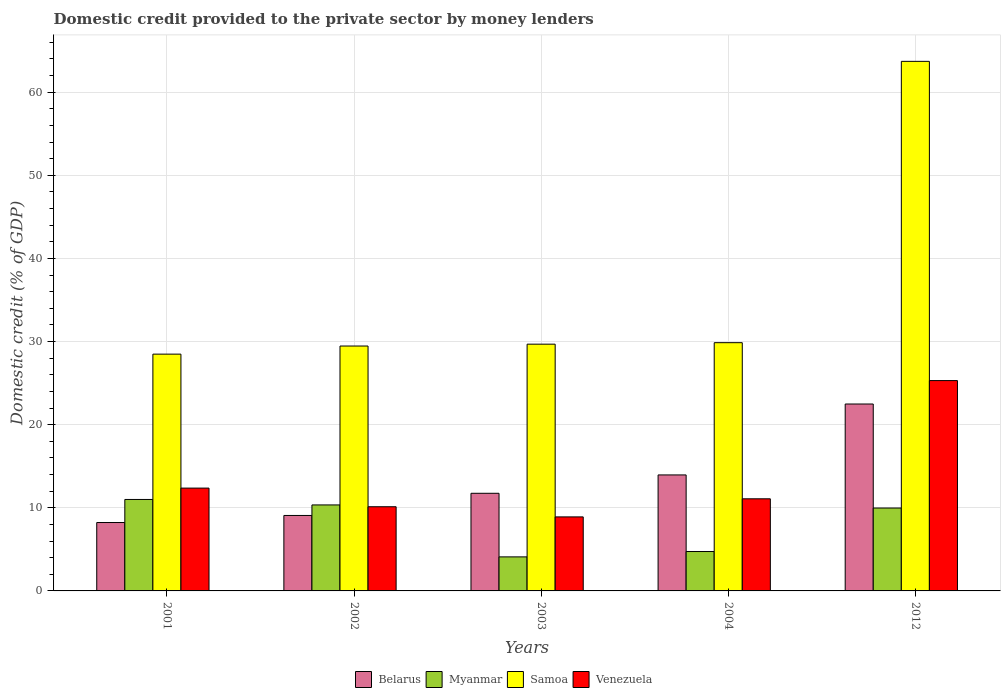How many groups of bars are there?
Your answer should be compact. 5. Are the number of bars per tick equal to the number of legend labels?
Offer a terse response. Yes. Are the number of bars on each tick of the X-axis equal?
Your answer should be very brief. Yes. How many bars are there on the 5th tick from the left?
Ensure brevity in your answer.  4. How many bars are there on the 5th tick from the right?
Offer a very short reply. 4. In how many cases, is the number of bars for a given year not equal to the number of legend labels?
Make the answer very short. 0. What is the domestic credit provided to the private sector by money lenders in Myanmar in 2001?
Give a very brief answer. 11. Across all years, what is the maximum domestic credit provided to the private sector by money lenders in Venezuela?
Offer a very short reply. 25.3. Across all years, what is the minimum domestic credit provided to the private sector by money lenders in Myanmar?
Your answer should be very brief. 4.1. In which year was the domestic credit provided to the private sector by money lenders in Myanmar minimum?
Your answer should be very brief. 2003. What is the total domestic credit provided to the private sector by money lenders in Myanmar in the graph?
Provide a succinct answer. 40.16. What is the difference between the domestic credit provided to the private sector by money lenders in Venezuela in 2001 and that in 2002?
Provide a short and direct response. 2.24. What is the difference between the domestic credit provided to the private sector by money lenders in Myanmar in 2012 and the domestic credit provided to the private sector by money lenders in Samoa in 2002?
Your answer should be very brief. -19.49. What is the average domestic credit provided to the private sector by money lenders in Myanmar per year?
Your answer should be very brief. 8.03. In the year 2004, what is the difference between the domestic credit provided to the private sector by money lenders in Myanmar and domestic credit provided to the private sector by money lenders in Belarus?
Provide a succinct answer. -9.21. What is the ratio of the domestic credit provided to the private sector by money lenders in Samoa in 2002 to that in 2012?
Your response must be concise. 0.46. Is the difference between the domestic credit provided to the private sector by money lenders in Myanmar in 2002 and 2004 greater than the difference between the domestic credit provided to the private sector by money lenders in Belarus in 2002 and 2004?
Make the answer very short. Yes. What is the difference between the highest and the second highest domestic credit provided to the private sector by money lenders in Myanmar?
Provide a short and direct response. 0.66. What is the difference between the highest and the lowest domestic credit provided to the private sector by money lenders in Samoa?
Give a very brief answer. 35.22. In how many years, is the domestic credit provided to the private sector by money lenders in Venezuela greater than the average domestic credit provided to the private sector by money lenders in Venezuela taken over all years?
Ensure brevity in your answer.  1. Is it the case that in every year, the sum of the domestic credit provided to the private sector by money lenders in Belarus and domestic credit provided to the private sector by money lenders in Venezuela is greater than the sum of domestic credit provided to the private sector by money lenders in Samoa and domestic credit provided to the private sector by money lenders in Myanmar?
Keep it short and to the point. No. What does the 1st bar from the left in 2004 represents?
Provide a short and direct response. Belarus. What does the 2nd bar from the right in 2004 represents?
Your answer should be compact. Samoa. How many bars are there?
Give a very brief answer. 20. Are all the bars in the graph horizontal?
Make the answer very short. No. How many years are there in the graph?
Your answer should be very brief. 5. What is the difference between two consecutive major ticks on the Y-axis?
Offer a terse response. 10. Are the values on the major ticks of Y-axis written in scientific E-notation?
Offer a terse response. No. Does the graph contain any zero values?
Offer a terse response. No. Where does the legend appear in the graph?
Your answer should be very brief. Bottom center. How many legend labels are there?
Keep it short and to the point. 4. How are the legend labels stacked?
Offer a terse response. Horizontal. What is the title of the graph?
Provide a short and direct response. Domestic credit provided to the private sector by money lenders. Does "Somalia" appear as one of the legend labels in the graph?
Offer a terse response. No. What is the label or title of the X-axis?
Offer a very short reply. Years. What is the label or title of the Y-axis?
Provide a succinct answer. Domestic credit (% of GDP). What is the Domestic credit (% of GDP) in Belarus in 2001?
Offer a very short reply. 8.23. What is the Domestic credit (% of GDP) of Myanmar in 2001?
Your answer should be compact. 11. What is the Domestic credit (% of GDP) of Samoa in 2001?
Make the answer very short. 28.49. What is the Domestic credit (% of GDP) of Venezuela in 2001?
Provide a succinct answer. 12.37. What is the Domestic credit (% of GDP) of Belarus in 2002?
Your answer should be very brief. 9.08. What is the Domestic credit (% of GDP) in Myanmar in 2002?
Keep it short and to the point. 10.34. What is the Domestic credit (% of GDP) in Samoa in 2002?
Give a very brief answer. 29.46. What is the Domestic credit (% of GDP) of Venezuela in 2002?
Provide a short and direct response. 10.13. What is the Domestic credit (% of GDP) of Belarus in 2003?
Your answer should be very brief. 11.75. What is the Domestic credit (% of GDP) in Myanmar in 2003?
Provide a succinct answer. 4.1. What is the Domestic credit (% of GDP) in Samoa in 2003?
Keep it short and to the point. 29.69. What is the Domestic credit (% of GDP) in Venezuela in 2003?
Ensure brevity in your answer.  8.91. What is the Domestic credit (% of GDP) in Belarus in 2004?
Make the answer very short. 13.95. What is the Domestic credit (% of GDP) of Myanmar in 2004?
Keep it short and to the point. 4.74. What is the Domestic credit (% of GDP) in Samoa in 2004?
Your response must be concise. 29.87. What is the Domestic credit (% of GDP) in Venezuela in 2004?
Keep it short and to the point. 11.08. What is the Domestic credit (% of GDP) of Belarus in 2012?
Offer a very short reply. 22.49. What is the Domestic credit (% of GDP) of Myanmar in 2012?
Offer a terse response. 9.97. What is the Domestic credit (% of GDP) in Samoa in 2012?
Offer a terse response. 63.71. What is the Domestic credit (% of GDP) in Venezuela in 2012?
Offer a very short reply. 25.3. Across all years, what is the maximum Domestic credit (% of GDP) in Belarus?
Keep it short and to the point. 22.49. Across all years, what is the maximum Domestic credit (% of GDP) of Myanmar?
Offer a terse response. 11. Across all years, what is the maximum Domestic credit (% of GDP) in Samoa?
Your response must be concise. 63.71. Across all years, what is the maximum Domestic credit (% of GDP) in Venezuela?
Your answer should be compact. 25.3. Across all years, what is the minimum Domestic credit (% of GDP) in Belarus?
Offer a terse response. 8.23. Across all years, what is the minimum Domestic credit (% of GDP) of Myanmar?
Make the answer very short. 4.1. Across all years, what is the minimum Domestic credit (% of GDP) of Samoa?
Your answer should be compact. 28.49. Across all years, what is the minimum Domestic credit (% of GDP) of Venezuela?
Ensure brevity in your answer.  8.91. What is the total Domestic credit (% of GDP) in Belarus in the graph?
Provide a short and direct response. 65.49. What is the total Domestic credit (% of GDP) in Myanmar in the graph?
Your response must be concise. 40.16. What is the total Domestic credit (% of GDP) in Samoa in the graph?
Offer a very short reply. 181.21. What is the total Domestic credit (% of GDP) in Venezuela in the graph?
Your response must be concise. 67.79. What is the difference between the Domestic credit (% of GDP) of Belarus in 2001 and that in 2002?
Provide a short and direct response. -0.85. What is the difference between the Domestic credit (% of GDP) of Myanmar in 2001 and that in 2002?
Your answer should be very brief. 0.66. What is the difference between the Domestic credit (% of GDP) of Samoa in 2001 and that in 2002?
Offer a terse response. -0.98. What is the difference between the Domestic credit (% of GDP) of Venezuela in 2001 and that in 2002?
Ensure brevity in your answer.  2.24. What is the difference between the Domestic credit (% of GDP) in Belarus in 2001 and that in 2003?
Offer a very short reply. -3.52. What is the difference between the Domestic credit (% of GDP) of Myanmar in 2001 and that in 2003?
Your answer should be very brief. 6.91. What is the difference between the Domestic credit (% of GDP) of Samoa in 2001 and that in 2003?
Your answer should be compact. -1.2. What is the difference between the Domestic credit (% of GDP) in Venezuela in 2001 and that in 2003?
Ensure brevity in your answer.  3.46. What is the difference between the Domestic credit (% of GDP) in Belarus in 2001 and that in 2004?
Keep it short and to the point. -5.72. What is the difference between the Domestic credit (% of GDP) of Myanmar in 2001 and that in 2004?
Make the answer very short. 6.26. What is the difference between the Domestic credit (% of GDP) of Samoa in 2001 and that in 2004?
Make the answer very short. -1.38. What is the difference between the Domestic credit (% of GDP) of Venezuela in 2001 and that in 2004?
Offer a very short reply. 1.29. What is the difference between the Domestic credit (% of GDP) in Belarus in 2001 and that in 2012?
Keep it short and to the point. -14.26. What is the difference between the Domestic credit (% of GDP) of Myanmar in 2001 and that in 2012?
Offer a terse response. 1.03. What is the difference between the Domestic credit (% of GDP) of Samoa in 2001 and that in 2012?
Make the answer very short. -35.22. What is the difference between the Domestic credit (% of GDP) of Venezuela in 2001 and that in 2012?
Give a very brief answer. -12.93. What is the difference between the Domestic credit (% of GDP) in Belarus in 2002 and that in 2003?
Make the answer very short. -2.67. What is the difference between the Domestic credit (% of GDP) in Myanmar in 2002 and that in 2003?
Offer a very short reply. 6.25. What is the difference between the Domestic credit (% of GDP) of Samoa in 2002 and that in 2003?
Ensure brevity in your answer.  -0.22. What is the difference between the Domestic credit (% of GDP) in Venezuela in 2002 and that in 2003?
Give a very brief answer. 1.22. What is the difference between the Domestic credit (% of GDP) of Belarus in 2002 and that in 2004?
Your answer should be very brief. -4.88. What is the difference between the Domestic credit (% of GDP) of Myanmar in 2002 and that in 2004?
Your answer should be very brief. 5.6. What is the difference between the Domestic credit (% of GDP) in Samoa in 2002 and that in 2004?
Provide a short and direct response. -0.4. What is the difference between the Domestic credit (% of GDP) in Venezuela in 2002 and that in 2004?
Offer a very short reply. -0.95. What is the difference between the Domestic credit (% of GDP) of Belarus in 2002 and that in 2012?
Make the answer very short. -13.41. What is the difference between the Domestic credit (% of GDP) of Myanmar in 2002 and that in 2012?
Your response must be concise. 0.37. What is the difference between the Domestic credit (% of GDP) of Samoa in 2002 and that in 2012?
Your response must be concise. -34.25. What is the difference between the Domestic credit (% of GDP) of Venezuela in 2002 and that in 2012?
Provide a short and direct response. -15.18. What is the difference between the Domestic credit (% of GDP) of Belarus in 2003 and that in 2004?
Offer a terse response. -2.21. What is the difference between the Domestic credit (% of GDP) in Myanmar in 2003 and that in 2004?
Keep it short and to the point. -0.64. What is the difference between the Domestic credit (% of GDP) of Samoa in 2003 and that in 2004?
Your answer should be compact. -0.18. What is the difference between the Domestic credit (% of GDP) of Venezuela in 2003 and that in 2004?
Offer a very short reply. -2.18. What is the difference between the Domestic credit (% of GDP) of Belarus in 2003 and that in 2012?
Keep it short and to the point. -10.74. What is the difference between the Domestic credit (% of GDP) of Myanmar in 2003 and that in 2012?
Your response must be concise. -5.88. What is the difference between the Domestic credit (% of GDP) of Samoa in 2003 and that in 2012?
Offer a terse response. -34.02. What is the difference between the Domestic credit (% of GDP) in Venezuela in 2003 and that in 2012?
Offer a terse response. -16.4. What is the difference between the Domestic credit (% of GDP) in Belarus in 2004 and that in 2012?
Offer a terse response. -8.53. What is the difference between the Domestic credit (% of GDP) in Myanmar in 2004 and that in 2012?
Offer a terse response. -5.23. What is the difference between the Domestic credit (% of GDP) of Samoa in 2004 and that in 2012?
Offer a terse response. -33.84. What is the difference between the Domestic credit (% of GDP) in Venezuela in 2004 and that in 2012?
Ensure brevity in your answer.  -14.22. What is the difference between the Domestic credit (% of GDP) in Belarus in 2001 and the Domestic credit (% of GDP) in Myanmar in 2002?
Your answer should be compact. -2.12. What is the difference between the Domestic credit (% of GDP) of Belarus in 2001 and the Domestic credit (% of GDP) of Samoa in 2002?
Ensure brevity in your answer.  -21.23. What is the difference between the Domestic credit (% of GDP) of Belarus in 2001 and the Domestic credit (% of GDP) of Venezuela in 2002?
Make the answer very short. -1.9. What is the difference between the Domestic credit (% of GDP) in Myanmar in 2001 and the Domestic credit (% of GDP) in Samoa in 2002?
Make the answer very short. -18.46. What is the difference between the Domestic credit (% of GDP) in Myanmar in 2001 and the Domestic credit (% of GDP) in Venezuela in 2002?
Your answer should be compact. 0.88. What is the difference between the Domestic credit (% of GDP) in Samoa in 2001 and the Domestic credit (% of GDP) in Venezuela in 2002?
Provide a short and direct response. 18.36. What is the difference between the Domestic credit (% of GDP) of Belarus in 2001 and the Domestic credit (% of GDP) of Myanmar in 2003?
Ensure brevity in your answer.  4.13. What is the difference between the Domestic credit (% of GDP) in Belarus in 2001 and the Domestic credit (% of GDP) in Samoa in 2003?
Provide a short and direct response. -21.46. What is the difference between the Domestic credit (% of GDP) of Belarus in 2001 and the Domestic credit (% of GDP) of Venezuela in 2003?
Make the answer very short. -0.68. What is the difference between the Domestic credit (% of GDP) of Myanmar in 2001 and the Domestic credit (% of GDP) of Samoa in 2003?
Provide a succinct answer. -18.68. What is the difference between the Domestic credit (% of GDP) in Myanmar in 2001 and the Domestic credit (% of GDP) in Venezuela in 2003?
Provide a short and direct response. 2.1. What is the difference between the Domestic credit (% of GDP) of Samoa in 2001 and the Domestic credit (% of GDP) of Venezuela in 2003?
Offer a terse response. 19.58. What is the difference between the Domestic credit (% of GDP) of Belarus in 2001 and the Domestic credit (% of GDP) of Myanmar in 2004?
Offer a very short reply. 3.49. What is the difference between the Domestic credit (% of GDP) of Belarus in 2001 and the Domestic credit (% of GDP) of Samoa in 2004?
Offer a very short reply. -21.64. What is the difference between the Domestic credit (% of GDP) in Belarus in 2001 and the Domestic credit (% of GDP) in Venezuela in 2004?
Provide a succinct answer. -2.85. What is the difference between the Domestic credit (% of GDP) in Myanmar in 2001 and the Domestic credit (% of GDP) in Samoa in 2004?
Your response must be concise. -18.86. What is the difference between the Domestic credit (% of GDP) of Myanmar in 2001 and the Domestic credit (% of GDP) of Venezuela in 2004?
Offer a very short reply. -0.08. What is the difference between the Domestic credit (% of GDP) of Samoa in 2001 and the Domestic credit (% of GDP) of Venezuela in 2004?
Offer a very short reply. 17.4. What is the difference between the Domestic credit (% of GDP) in Belarus in 2001 and the Domestic credit (% of GDP) in Myanmar in 2012?
Offer a very short reply. -1.74. What is the difference between the Domestic credit (% of GDP) of Belarus in 2001 and the Domestic credit (% of GDP) of Samoa in 2012?
Provide a short and direct response. -55.48. What is the difference between the Domestic credit (% of GDP) in Belarus in 2001 and the Domestic credit (% of GDP) in Venezuela in 2012?
Your response must be concise. -17.07. What is the difference between the Domestic credit (% of GDP) in Myanmar in 2001 and the Domestic credit (% of GDP) in Samoa in 2012?
Give a very brief answer. -52.71. What is the difference between the Domestic credit (% of GDP) in Myanmar in 2001 and the Domestic credit (% of GDP) in Venezuela in 2012?
Keep it short and to the point. -14.3. What is the difference between the Domestic credit (% of GDP) in Samoa in 2001 and the Domestic credit (% of GDP) in Venezuela in 2012?
Offer a very short reply. 3.18. What is the difference between the Domestic credit (% of GDP) of Belarus in 2002 and the Domestic credit (% of GDP) of Myanmar in 2003?
Offer a terse response. 4.98. What is the difference between the Domestic credit (% of GDP) of Belarus in 2002 and the Domestic credit (% of GDP) of Samoa in 2003?
Provide a succinct answer. -20.61. What is the difference between the Domestic credit (% of GDP) of Belarus in 2002 and the Domestic credit (% of GDP) of Venezuela in 2003?
Ensure brevity in your answer.  0.17. What is the difference between the Domestic credit (% of GDP) of Myanmar in 2002 and the Domestic credit (% of GDP) of Samoa in 2003?
Offer a very short reply. -19.34. What is the difference between the Domestic credit (% of GDP) of Myanmar in 2002 and the Domestic credit (% of GDP) of Venezuela in 2003?
Ensure brevity in your answer.  1.44. What is the difference between the Domestic credit (% of GDP) in Samoa in 2002 and the Domestic credit (% of GDP) in Venezuela in 2003?
Offer a very short reply. 20.56. What is the difference between the Domestic credit (% of GDP) in Belarus in 2002 and the Domestic credit (% of GDP) in Myanmar in 2004?
Provide a succinct answer. 4.34. What is the difference between the Domestic credit (% of GDP) of Belarus in 2002 and the Domestic credit (% of GDP) of Samoa in 2004?
Offer a terse response. -20.79. What is the difference between the Domestic credit (% of GDP) in Belarus in 2002 and the Domestic credit (% of GDP) in Venezuela in 2004?
Offer a very short reply. -2. What is the difference between the Domestic credit (% of GDP) of Myanmar in 2002 and the Domestic credit (% of GDP) of Samoa in 2004?
Give a very brief answer. -19.52. What is the difference between the Domestic credit (% of GDP) of Myanmar in 2002 and the Domestic credit (% of GDP) of Venezuela in 2004?
Offer a terse response. -0.74. What is the difference between the Domestic credit (% of GDP) in Samoa in 2002 and the Domestic credit (% of GDP) in Venezuela in 2004?
Your answer should be very brief. 18.38. What is the difference between the Domestic credit (% of GDP) in Belarus in 2002 and the Domestic credit (% of GDP) in Myanmar in 2012?
Make the answer very short. -0.9. What is the difference between the Domestic credit (% of GDP) in Belarus in 2002 and the Domestic credit (% of GDP) in Samoa in 2012?
Give a very brief answer. -54.63. What is the difference between the Domestic credit (% of GDP) in Belarus in 2002 and the Domestic credit (% of GDP) in Venezuela in 2012?
Your response must be concise. -16.23. What is the difference between the Domestic credit (% of GDP) in Myanmar in 2002 and the Domestic credit (% of GDP) in Samoa in 2012?
Provide a short and direct response. -53.36. What is the difference between the Domestic credit (% of GDP) of Myanmar in 2002 and the Domestic credit (% of GDP) of Venezuela in 2012?
Make the answer very short. -14.96. What is the difference between the Domestic credit (% of GDP) of Samoa in 2002 and the Domestic credit (% of GDP) of Venezuela in 2012?
Offer a terse response. 4.16. What is the difference between the Domestic credit (% of GDP) of Belarus in 2003 and the Domestic credit (% of GDP) of Myanmar in 2004?
Offer a very short reply. 7.01. What is the difference between the Domestic credit (% of GDP) of Belarus in 2003 and the Domestic credit (% of GDP) of Samoa in 2004?
Offer a very short reply. -18.12. What is the difference between the Domestic credit (% of GDP) in Belarus in 2003 and the Domestic credit (% of GDP) in Venezuela in 2004?
Your answer should be compact. 0.66. What is the difference between the Domestic credit (% of GDP) of Myanmar in 2003 and the Domestic credit (% of GDP) of Samoa in 2004?
Provide a succinct answer. -25.77. What is the difference between the Domestic credit (% of GDP) in Myanmar in 2003 and the Domestic credit (% of GDP) in Venezuela in 2004?
Your answer should be compact. -6.99. What is the difference between the Domestic credit (% of GDP) in Samoa in 2003 and the Domestic credit (% of GDP) in Venezuela in 2004?
Provide a short and direct response. 18.6. What is the difference between the Domestic credit (% of GDP) of Belarus in 2003 and the Domestic credit (% of GDP) of Myanmar in 2012?
Offer a very short reply. 1.77. What is the difference between the Domestic credit (% of GDP) in Belarus in 2003 and the Domestic credit (% of GDP) in Samoa in 2012?
Give a very brief answer. -51.96. What is the difference between the Domestic credit (% of GDP) of Belarus in 2003 and the Domestic credit (% of GDP) of Venezuela in 2012?
Provide a short and direct response. -13.56. What is the difference between the Domestic credit (% of GDP) in Myanmar in 2003 and the Domestic credit (% of GDP) in Samoa in 2012?
Offer a very short reply. -59.61. What is the difference between the Domestic credit (% of GDP) in Myanmar in 2003 and the Domestic credit (% of GDP) in Venezuela in 2012?
Give a very brief answer. -21.21. What is the difference between the Domestic credit (% of GDP) of Samoa in 2003 and the Domestic credit (% of GDP) of Venezuela in 2012?
Your answer should be compact. 4.38. What is the difference between the Domestic credit (% of GDP) in Belarus in 2004 and the Domestic credit (% of GDP) in Myanmar in 2012?
Provide a succinct answer. 3.98. What is the difference between the Domestic credit (% of GDP) of Belarus in 2004 and the Domestic credit (% of GDP) of Samoa in 2012?
Offer a very short reply. -49.76. What is the difference between the Domestic credit (% of GDP) of Belarus in 2004 and the Domestic credit (% of GDP) of Venezuela in 2012?
Your response must be concise. -11.35. What is the difference between the Domestic credit (% of GDP) in Myanmar in 2004 and the Domestic credit (% of GDP) in Samoa in 2012?
Your response must be concise. -58.97. What is the difference between the Domestic credit (% of GDP) of Myanmar in 2004 and the Domestic credit (% of GDP) of Venezuela in 2012?
Provide a succinct answer. -20.56. What is the difference between the Domestic credit (% of GDP) of Samoa in 2004 and the Domestic credit (% of GDP) of Venezuela in 2012?
Provide a succinct answer. 4.56. What is the average Domestic credit (% of GDP) in Belarus per year?
Provide a succinct answer. 13.1. What is the average Domestic credit (% of GDP) in Myanmar per year?
Offer a very short reply. 8.03. What is the average Domestic credit (% of GDP) of Samoa per year?
Offer a terse response. 36.24. What is the average Domestic credit (% of GDP) of Venezuela per year?
Your answer should be compact. 13.56. In the year 2001, what is the difference between the Domestic credit (% of GDP) in Belarus and Domestic credit (% of GDP) in Myanmar?
Your answer should be very brief. -2.77. In the year 2001, what is the difference between the Domestic credit (% of GDP) in Belarus and Domestic credit (% of GDP) in Samoa?
Give a very brief answer. -20.26. In the year 2001, what is the difference between the Domestic credit (% of GDP) in Belarus and Domestic credit (% of GDP) in Venezuela?
Offer a terse response. -4.14. In the year 2001, what is the difference between the Domestic credit (% of GDP) in Myanmar and Domestic credit (% of GDP) in Samoa?
Give a very brief answer. -17.48. In the year 2001, what is the difference between the Domestic credit (% of GDP) of Myanmar and Domestic credit (% of GDP) of Venezuela?
Give a very brief answer. -1.37. In the year 2001, what is the difference between the Domestic credit (% of GDP) of Samoa and Domestic credit (% of GDP) of Venezuela?
Keep it short and to the point. 16.12. In the year 2002, what is the difference between the Domestic credit (% of GDP) in Belarus and Domestic credit (% of GDP) in Myanmar?
Offer a terse response. -1.27. In the year 2002, what is the difference between the Domestic credit (% of GDP) in Belarus and Domestic credit (% of GDP) in Samoa?
Your answer should be compact. -20.38. In the year 2002, what is the difference between the Domestic credit (% of GDP) in Belarus and Domestic credit (% of GDP) in Venezuela?
Offer a terse response. -1.05. In the year 2002, what is the difference between the Domestic credit (% of GDP) of Myanmar and Domestic credit (% of GDP) of Samoa?
Provide a short and direct response. -19.12. In the year 2002, what is the difference between the Domestic credit (% of GDP) in Myanmar and Domestic credit (% of GDP) in Venezuela?
Offer a terse response. 0.22. In the year 2002, what is the difference between the Domestic credit (% of GDP) in Samoa and Domestic credit (% of GDP) in Venezuela?
Your response must be concise. 19.33. In the year 2003, what is the difference between the Domestic credit (% of GDP) in Belarus and Domestic credit (% of GDP) in Myanmar?
Offer a terse response. 7.65. In the year 2003, what is the difference between the Domestic credit (% of GDP) of Belarus and Domestic credit (% of GDP) of Samoa?
Your answer should be very brief. -17.94. In the year 2003, what is the difference between the Domestic credit (% of GDP) in Belarus and Domestic credit (% of GDP) in Venezuela?
Your answer should be very brief. 2.84. In the year 2003, what is the difference between the Domestic credit (% of GDP) of Myanmar and Domestic credit (% of GDP) of Samoa?
Offer a terse response. -25.59. In the year 2003, what is the difference between the Domestic credit (% of GDP) in Myanmar and Domestic credit (% of GDP) in Venezuela?
Keep it short and to the point. -4.81. In the year 2003, what is the difference between the Domestic credit (% of GDP) of Samoa and Domestic credit (% of GDP) of Venezuela?
Make the answer very short. 20.78. In the year 2004, what is the difference between the Domestic credit (% of GDP) of Belarus and Domestic credit (% of GDP) of Myanmar?
Offer a terse response. 9.21. In the year 2004, what is the difference between the Domestic credit (% of GDP) in Belarus and Domestic credit (% of GDP) in Samoa?
Give a very brief answer. -15.91. In the year 2004, what is the difference between the Domestic credit (% of GDP) of Belarus and Domestic credit (% of GDP) of Venezuela?
Make the answer very short. 2.87. In the year 2004, what is the difference between the Domestic credit (% of GDP) in Myanmar and Domestic credit (% of GDP) in Samoa?
Your answer should be very brief. -25.13. In the year 2004, what is the difference between the Domestic credit (% of GDP) in Myanmar and Domestic credit (% of GDP) in Venezuela?
Provide a short and direct response. -6.34. In the year 2004, what is the difference between the Domestic credit (% of GDP) in Samoa and Domestic credit (% of GDP) in Venezuela?
Provide a short and direct response. 18.78. In the year 2012, what is the difference between the Domestic credit (% of GDP) in Belarus and Domestic credit (% of GDP) in Myanmar?
Offer a terse response. 12.51. In the year 2012, what is the difference between the Domestic credit (% of GDP) of Belarus and Domestic credit (% of GDP) of Samoa?
Make the answer very short. -41.22. In the year 2012, what is the difference between the Domestic credit (% of GDP) in Belarus and Domestic credit (% of GDP) in Venezuela?
Your answer should be very brief. -2.82. In the year 2012, what is the difference between the Domestic credit (% of GDP) of Myanmar and Domestic credit (% of GDP) of Samoa?
Offer a very short reply. -53.74. In the year 2012, what is the difference between the Domestic credit (% of GDP) in Myanmar and Domestic credit (% of GDP) in Venezuela?
Offer a very short reply. -15.33. In the year 2012, what is the difference between the Domestic credit (% of GDP) of Samoa and Domestic credit (% of GDP) of Venezuela?
Your answer should be very brief. 38.41. What is the ratio of the Domestic credit (% of GDP) of Belarus in 2001 to that in 2002?
Your answer should be compact. 0.91. What is the ratio of the Domestic credit (% of GDP) of Myanmar in 2001 to that in 2002?
Your answer should be compact. 1.06. What is the ratio of the Domestic credit (% of GDP) in Samoa in 2001 to that in 2002?
Ensure brevity in your answer.  0.97. What is the ratio of the Domestic credit (% of GDP) of Venezuela in 2001 to that in 2002?
Your response must be concise. 1.22. What is the ratio of the Domestic credit (% of GDP) in Belarus in 2001 to that in 2003?
Offer a very short reply. 0.7. What is the ratio of the Domestic credit (% of GDP) in Myanmar in 2001 to that in 2003?
Ensure brevity in your answer.  2.69. What is the ratio of the Domestic credit (% of GDP) in Samoa in 2001 to that in 2003?
Ensure brevity in your answer.  0.96. What is the ratio of the Domestic credit (% of GDP) in Venezuela in 2001 to that in 2003?
Offer a very short reply. 1.39. What is the ratio of the Domestic credit (% of GDP) of Belarus in 2001 to that in 2004?
Keep it short and to the point. 0.59. What is the ratio of the Domestic credit (% of GDP) in Myanmar in 2001 to that in 2004?
Keep it short and to the point. 2.32. What is the ratio of the Domestic credit (% of GDP) in Samoa in 2001 to that in 2004?
Your answer should be very brief. 0.95. What is the ratio of the Domestic credit (% of GDP) of Venezuela in 2001 to that in 2004?
Provide a short and direct response. 1.12. What is the ratio of the Domestic credit (% of GDP) in Belarus in 2001 to that in 2012?
Provide a succinct answer. 0.37. What is the ratio of the Domestic credit (% of GDP) in Myanmar in 2001 to that in 2012?
Provide a short and direct response. 1.1. What is the ratio of the Domestic credit (% of GDP) of Samoa in 2001 to that in 2012?
Your response must be concise. 0.45. What is the ratio of the Domestic credit (% of GDP) of Venezuela in 2001 to that in 2012?
Keep it short and to the point. 0.49. What is the ratio of the Domestic credit (% of GDP) in Belarus in 2002 to that in 2003?
Provide a short and direct response. 0.77. What is the ratio of the Domestic credit (% of GDP) in Myanmar in 2002 to that in 2003?
Your answer should be compact. 2.53. What is the ratio of the Domestic credit (% of GDP) of Venezuela in 2002 to that in 2003?
Ensure brevity in your answer.  1.14. What is the ratio of the Domestic credit (% of GDP) in Belarus in 2002 to that in 2004?
Provide a short and direct response. 0.65. What is the ratio of the Domestic credit (% of GDP) in Myanmar in 2002 to that in 2004?
Provide a succinct answer. 2.18. What is the ratio of the Domestic credit (% of GDP) in Samoa in 2002 to that in 2004?
Your answer should be very brief. 0.99. What is the ratio of the Domestic credit (% of GDP) in Venezuela in 2002 to that in 2004?
Give a very brief answer. 0.91. What is the ratio of the Domestic credit (% of GDP) in Belarus in 2002 to that in 2012?
Offer a terse response. 0.4. What is the ratio of the Domestic credit (% of GDP) of Myanmar in 2002 to that in 2012?
Offer a very short reply. 1.04. What is the ratio of the Domestic credit (% of GDP) in Samoa in 2002 to that in 2012?
Ensure brevity in your answer.  0.46. What is the ratio of the Domestic credit (% of GDP) of Venezuela in 2002 to that in 2012?
Provide a short and direct response. 0.4. What is the ratio of the Domestic credit (% of GDP) in Belarus in 2003 to that in 2004?
Make the answer very short. 0.84. What is the ratio of the Domestic credit (% of GDP) in Myanmar in 2003 to that in 2004?
Your answer should be very brief. 0.86. What is the ratio of the Domestic credit (% of GDP) of Samoa in 2003 to that in 2004?
Keep it short and to the point. 0.99. What is the ratio of the Domestic credit (% of GDP) of Venezuela in 2003 to that in 2004?
Offer a terse response. 0.8. What is the ratio of the Domestic credit (% of GDP) of Belarus in 2003 to that in 2012?
Your answer should be compact. 0.52. What is the ratio of the Domestic credit (% of GDP) of Myanmar in 2003 to that in 2012?
Your response must be concise. 0.41. What is the ratio of the Domestic credit (% of GDP) of Samoa in 2003 to that in 2012?
Ensure brevity in your answer.  0.47. What is the ratio of the Domestic credit (% of GDP) of Venezuela in 2003 to that in 2012?
Ensure brevity in your answer.  0.35. What is the ratio of the Domestic credit (% of GDP) of Belarus in 2004 to that in 2012?
Provide a succinct answer. 0.62. What is the ratio of the Domestic credit (% of GDP) in Myanmar in 2004 to that in 2012?
Offer a terse response. 0.48. What is the ratio of the Domestic credit (% of GDP) of Samoa in 2004 to that in 2012?
Your answer should be very brief. 0.47. What is the ratio of the Domestic credit (% of GDP) in Venezuela in 2004 to that in 2012?
Your response must be concise. 0.44. What is the difference between the highest and the second highest Domestic credit (% of GDP) in Belarus?
Provide a succinct answer. 8.53. What is the difference between the highest and the second highest Domestic credit (% of GDP) in Myanmar?
Provide a short and direct response. 0.66. What is the difference between the highest and the second highest Domestic credit (% of GDP) in Samoa?
Offer a terse response. 33.84. What is the difference between the highest and the second highest Domestic credit (% of GDP) of Venezuela?
Provide a succinct answer. 12.93. What is the difference between the highest and the lowest Domestic credit (% of GDP) in Belarus?
Offer a terse response. 14.26. What is the difference between the highest and the lowest Domestic credit (% of GDP) of Myanmar?
Your answer should be very brief. 6.91. What is the difference between the highest and the lowest Domestic credit (% of GDP) in Samoa?
Your answer should be very brief. 35.22. What is the difference between the highest and the lowest Domestic credit (% of GDP) in Venezuela?
Offer a terse response. 16.4. 